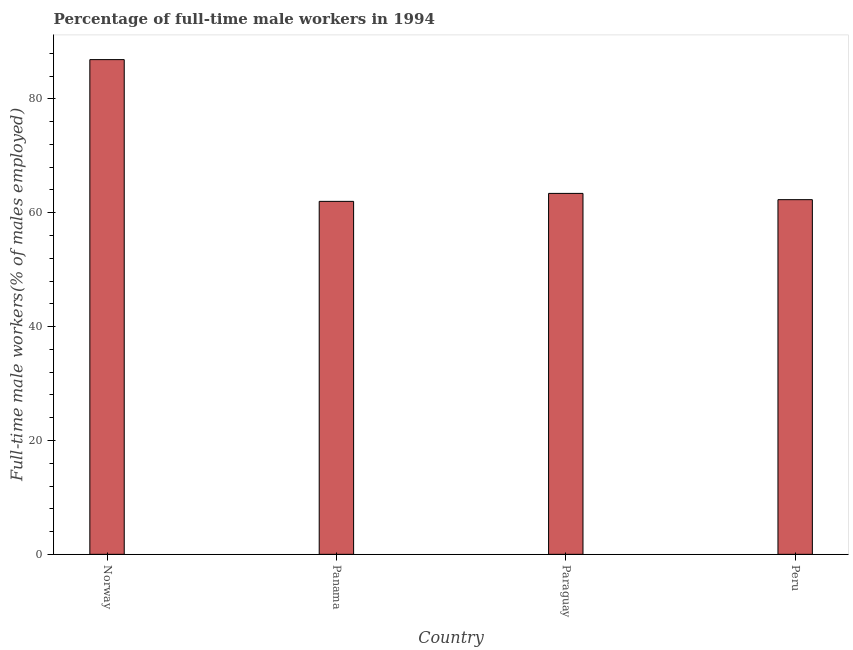What is the title of the graph?
Provide a short and direct response. Percentage of full-time male workers in 1994. What is the label or title of the X-axis?
Offer a terse response. Country. What is the label or title of the Y-axis?
Offer a terse response. Full-time male workers(% of males employed). What is the percentage of full-time male workers in Peru?
Offer a very short reply. 62.3. Across all countries, what is the maximum percentage of full-time male workers?
Offer a terse response. 86.9. In which country was the percentage of full-time male workers maximum?
Ensure brevity in your answer.  Norway. In which country was the percentage of full-time male workers minimum?
Your answer should be very brief. Panama. What is the sum of the percentage of full-time male workers?
Your answer should be compact. 274.6. What is the difference between the percentage of full-time male workers in Norway and Panama?
Offer a terse response. 24.9. What is the average percentage of full-time male workers per country?
Ensure brevity in your answer.  68.65. What is the median percentage of full-time male workers?
Your response must be concise. 62.85. What is the ratio of the percentage of full-time male workers in Norway to that in Panama?
Provide a succinct answer. 1.4. Is the difference between the percentage of full-time male workers in Panama and Peru greater than the difference between any two countries?
Give a very brief answer. No. What is the difference between the highest and the second highest percentage of full-time male workers?
Give a very brief answer. 23.5. What is the difference between the highest and the lowest percentage of full-time male workers?
Provide a short and direct response. 24.9. How many countries are there in the graph?
Provide a short and direct response. 4. Are the values on the major ticks of Y-axis written in scientific E-notation?
Provide a succinct answer. No. What is the Full-time male workers(% of males employed) of Norway?
Ensure brevity in your answer.  86.9. What is the Full-time male workers(% of males employed) in Panama?
Make the answer very short. 62. What is the Full-time male workers(% of males employed) in Paraguay?
Make the answer very short. 63.4. What is the Full-time male workers(% of males employed) in Peru?
Offer a very short reply. 62.3. What is the difference between the Full-time male workers(% of males employed) in Norway and Panama?
Provide a short and direct response. 24.9. What is the difference between the Full-time male workers(% of males employed) in Norway and Peru?
Your response must be concise. 24.6. What is the ratio of the Full-time male workers(% of males employed) in Norway to that in Panama?
Provide a succinct answer. 1.4. What is the ratio of the Full-time male workers(% of males employed) in Norway to that in Paraguay?
Give a very brief answer. 1.37. What is the ratio of the Full-time male workers(% of males employed) in Norway to that in Peru?
Offer a terse response. 1.4. What is the ratio of the Full-time male workers(% of males employed) in Panama to that in Paraguay?
Your answer should be very brief. 0.98. What is the ratio of the Full-time male workers(% of males employed) in Panama to that in Peru?
Make the answer very short. 0.99. 